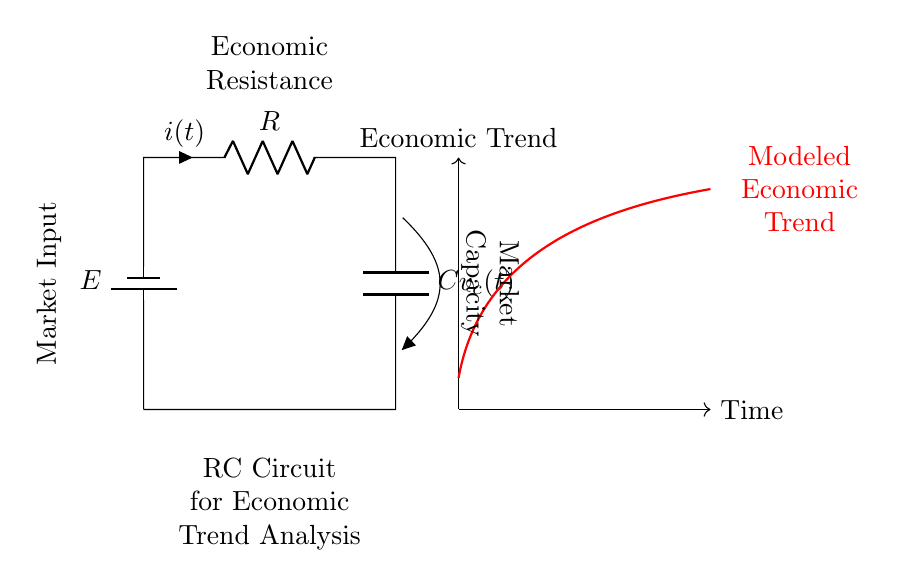What components are in this circuit? The circuit consists of a battery, a resistor, and a capacitor. These components are represented by symbols indicating their functions in the circuit.
Answer: battery, resistor, capacitor What is the current in the circuit represented as? The current is represented as "i(t)", indicating that it is a function of time. This notation shows that current may vary over time depending on the circuit conditions.
Answer: i(t) What does the symbol E represent? The symbol E represents the voltage of the battery, which is the source of power for the circuit. It provides the potential difference needed to drive current through the components.
Answer: E What is the economic interpretation of the resistor? The resistor represents economic resistance, which reflects the factors that impede or slow down economic growth or trends. This parallels how a resistor limits current flow in the circuit.
Answer: Economic Resistance Why is the capacitor important in this circuit? The capacitor represents market capacity, which stores economic potential over time. Its charge and discharge behavior can model how markets respond to changes in trends, indicating how economic conditions build up or decline.
Answer: Market Capacity How do the current and voltage relate in this circuit? In an RC circuit, the current and voltage are related through the charging and discharging behavior of the capacitor. The rate of change of voltage across the capacitor is proportional to the current flowing through the circuit, as dictated by the formula involving resistance and capacitance.
Answer: Current and Voltage Relation What does the red curve in the diagram represent? The red curve labeled "Modeled Economic Trend" represents the theoretical economic trend over time, illustrating how economic indicators may change as influenced by the RC circuit components, effectively modeling the system's response to inputs.
Answer: Modeled Economic Trend 